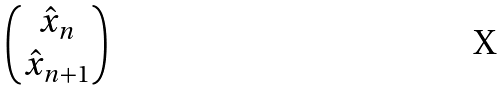<formula> <loc_0><loc_0><loc_500><loc_500>\begin{pmatrix} \hat { x } _ { n } \\ \hat { x } _ { n + 1 } \end{pmatrix}</formula> 